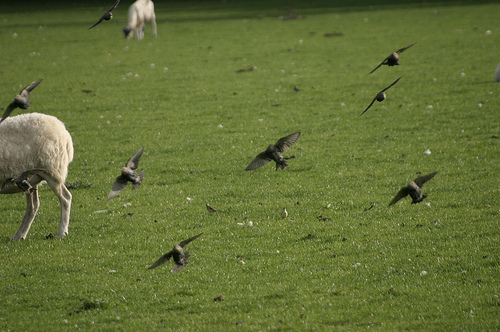How does the presence of the birds affect the atmosphere of the scene? The birds in flight add a dynamic element to the otherwise still and peaceful field. Their presence introduces a sense of liveliness and unpredictability, contrasting beautifully with the calm demeanor of the grazing sheep. 